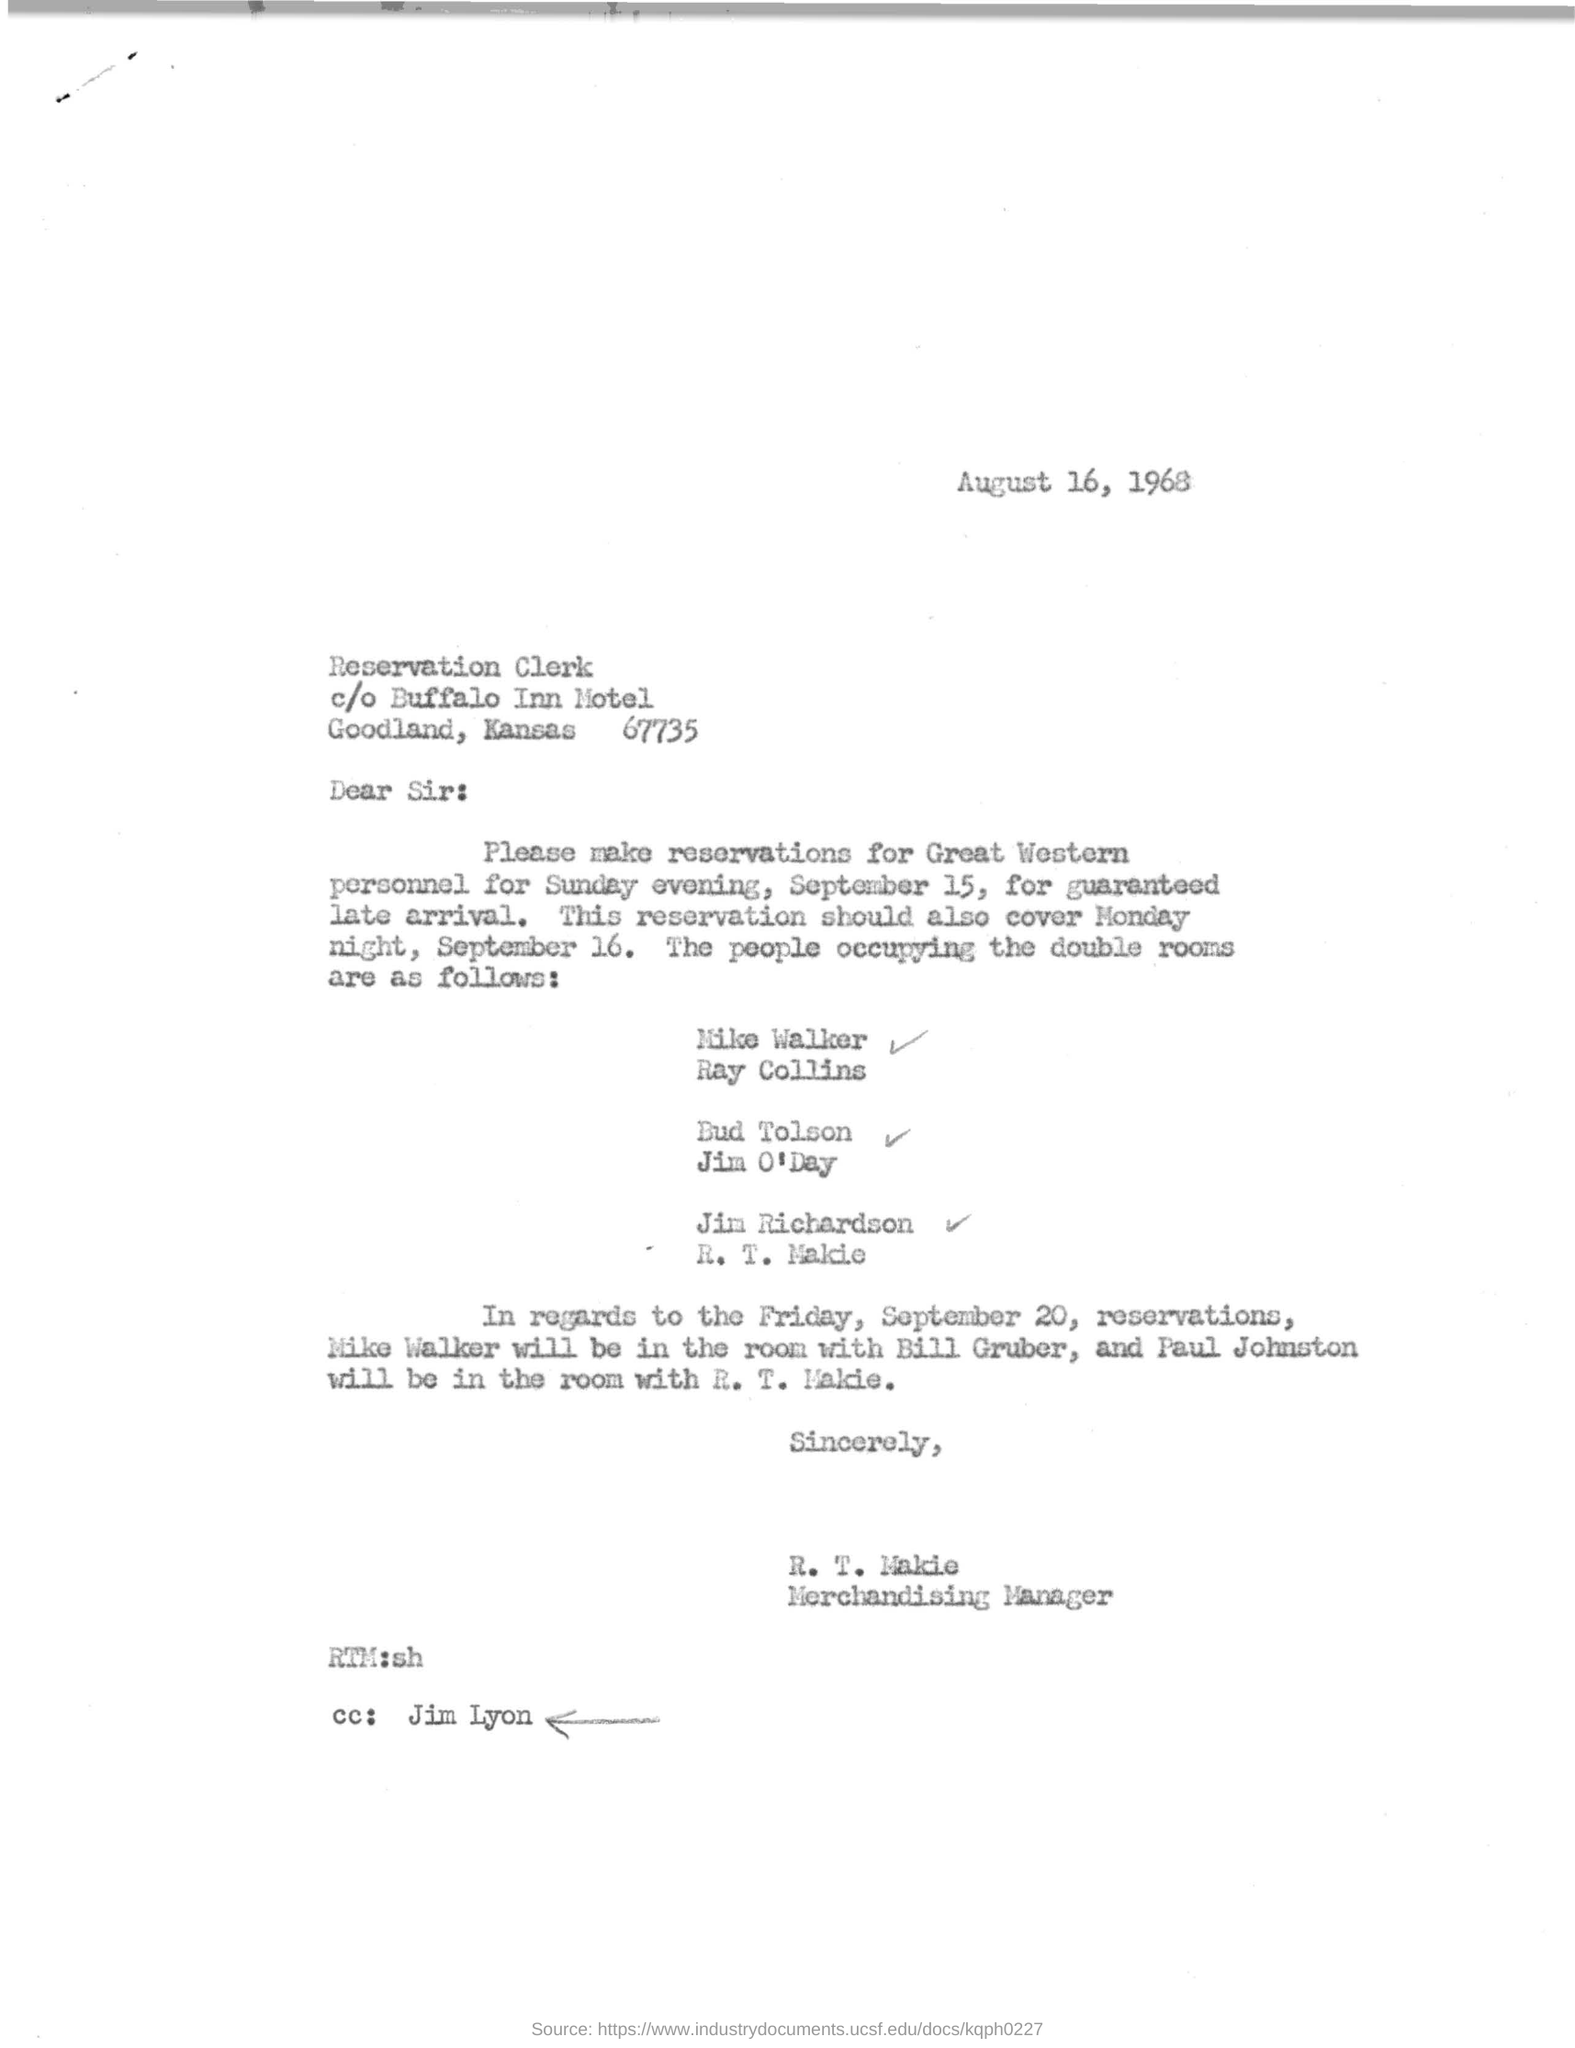Highlight a few significant elements in this photo. Jim Lyon is mentioned in the cc. The sender of this letter is R. T. Makie. R. T. Makie is the Merchandising Manager. 